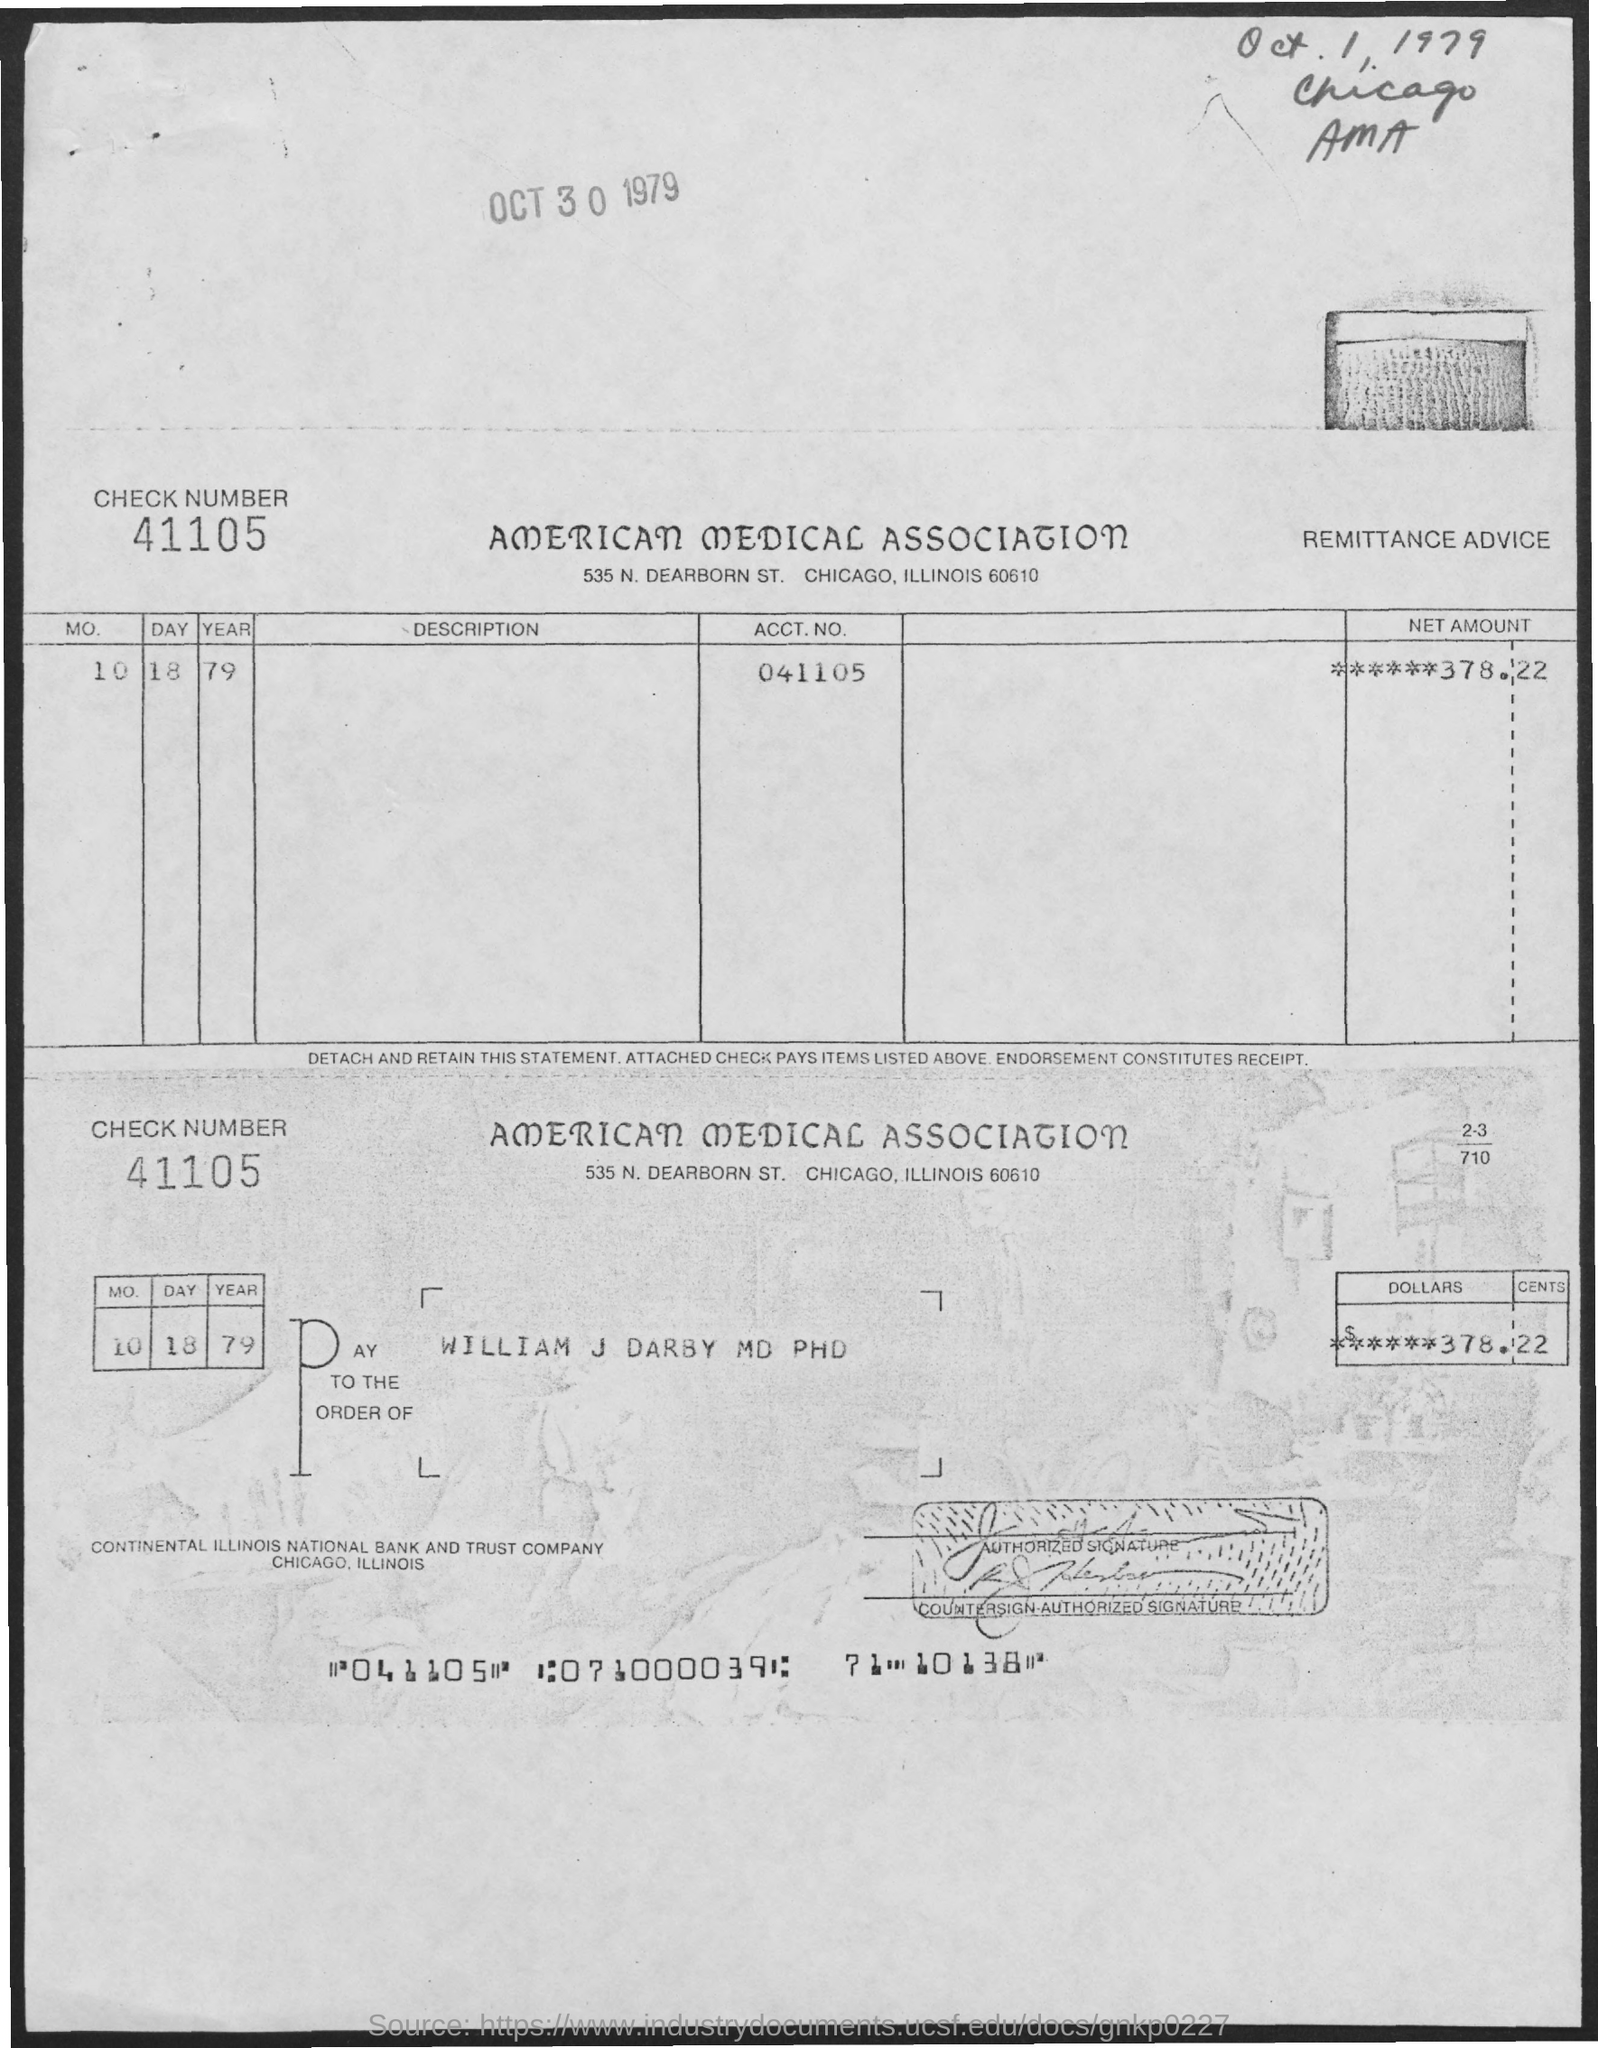Give some essential details in this illustration. The check indicates that the date mentioned on it is October 18, 1979. The account number provided in the receipt is ACCT.NO 041105... The check provided the name of the payee as WILLIAM J DARBY MD PHD. The check amount mentioned in the check is $378.22. The check number mentioned here is 41105. 